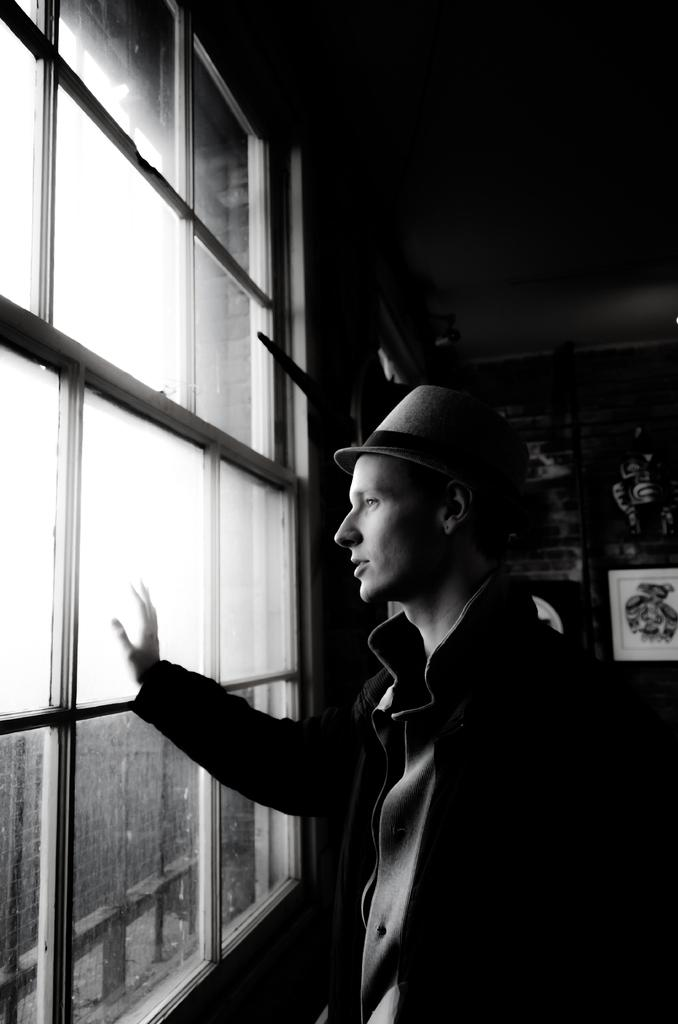What is the man in the image doing? The man is standing beside a window in the image. What can be seen on the wall in the image? There are frames on a wall in the image. What is visible on the left side of the image? There are buildings visible on the left side of the image. What part of the natural environment is visible in the image? The sky is visible in the image. Can you tell me how many dogs are visible in the image? There are no dogs present in the image. What type of paper is being used to create the buildings on the left side of the image? The buildings are not made of paper; they are actual structures visible in the image. 